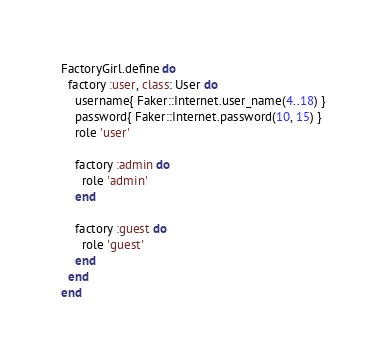Convert code to text. <code><loc_0><loc_0><loc_500><loc_500><_Ruby_>FactoryGirl.define do
  factory :user, class: User do
    username{ Faker::Internet.user_name(4..18) }
    password{ Faker::Internet.password(10, 15) }
    role 'user'

    factory :admin do
      role 'admin'
    end

    factory :guest do
      role 'guest'
    end
  end
end
</code> 